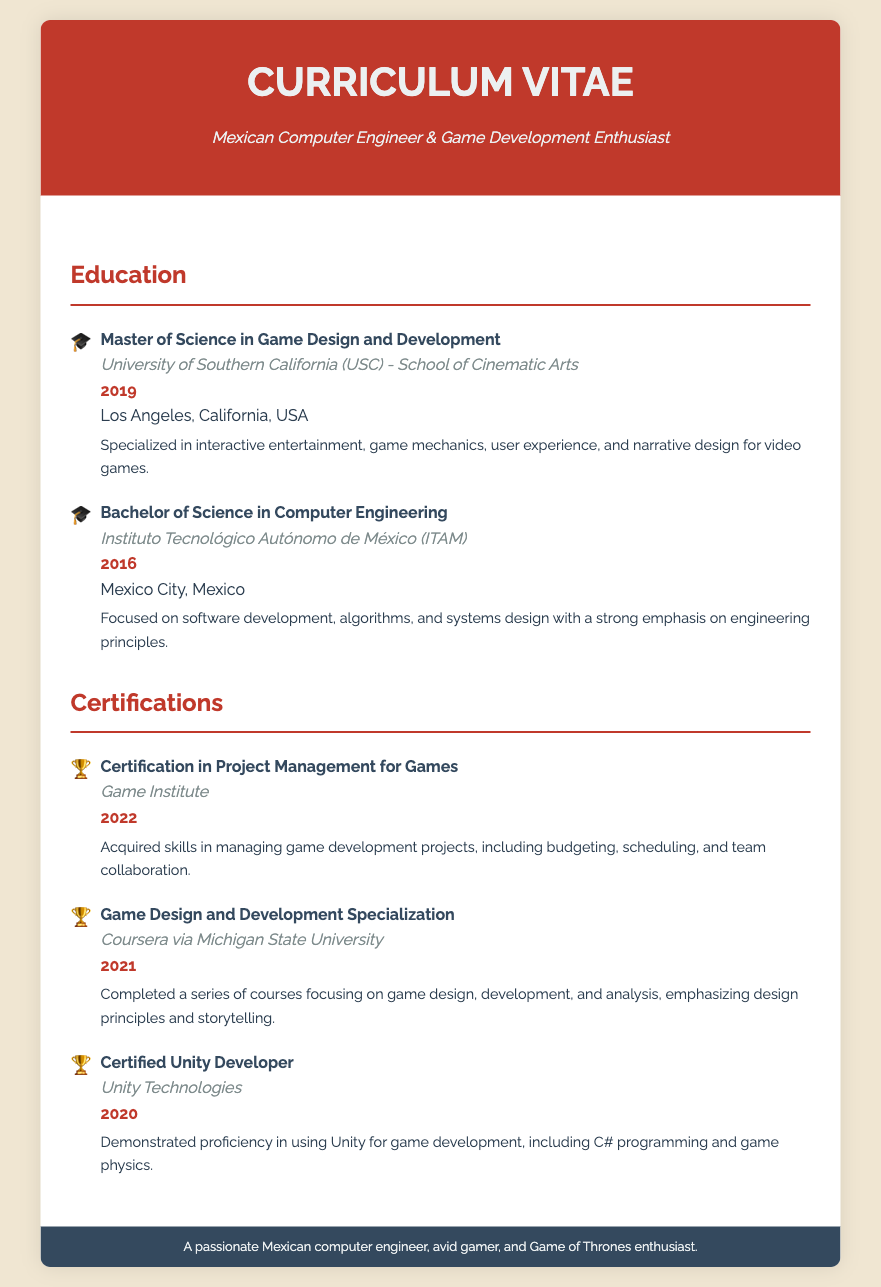what is the highest degree obtained? The highest degree listed in the document is the Master of Science in Game Design and Development.
Answer: Master of Science in Game Design and Development what university awarded the Bachelor's degree? The institution that awarded the Bachelor's degree is the Instituto Tecnológico Autónomo de México (ITAM).
Answer: Instituto Tecnológico Autónomo de México (ITAM) in which year was the Master's degree obtained? The year the Master's degree was obtained is specified in the document.
Answer: 2019 which certification was obtained in 2020? The document lists the certifications along with their years, the one obtained in 2020 is the Certified Unity Developer.
Answer: Certified Unity Developer how many certifications are listed in the document? The total number of certifications found in the document can be counted from the certifications section.
Answer: 3 what is the location of the institution that awarded the Bachelor's degree? The document specifies the location for each education item; ITAM is located in Mexico City.
Answer: Mexico City, Mexico which organization issued the Certification in Project Management for Games? The issuing organization for this certification is mentioned in the certification details.
Answer: Game Institute what is the main focus of the Master's degree program? The description of the Master's degree outlines its specialization areas.
Answer: Interactive entertainment 